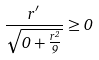Convert formula to latex. <formula><loc_0><loc_0><loc_500><loc_500>\frac { r ^ { \prime } } { \sqrt { 0 + \frac { r ^ { 2 } } { 9 } } } \geq 0</formula> 